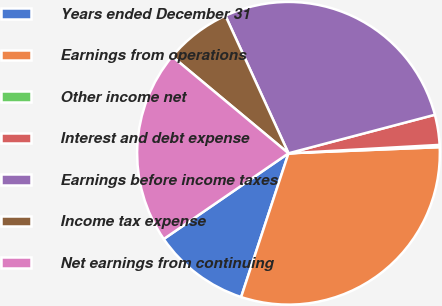Convert chart. <chart><loc_0><loc_0><loc_500><loc_500><pie_chart><fcel>Years ended December 31<fcel>Earnings from operations<fcel>Other income net<fcel>Interest and debt expense<fcel>Earnings before income taxes<fcel>Income tax expense<fcel>Net earnings from continuing<nl><fcel>10.35%<fcel>30.71%<fcel>0.24%<fcel>3.21%<fcel>27.74%<fcel>7.11%<fcel>20.63%<nl></chart> 